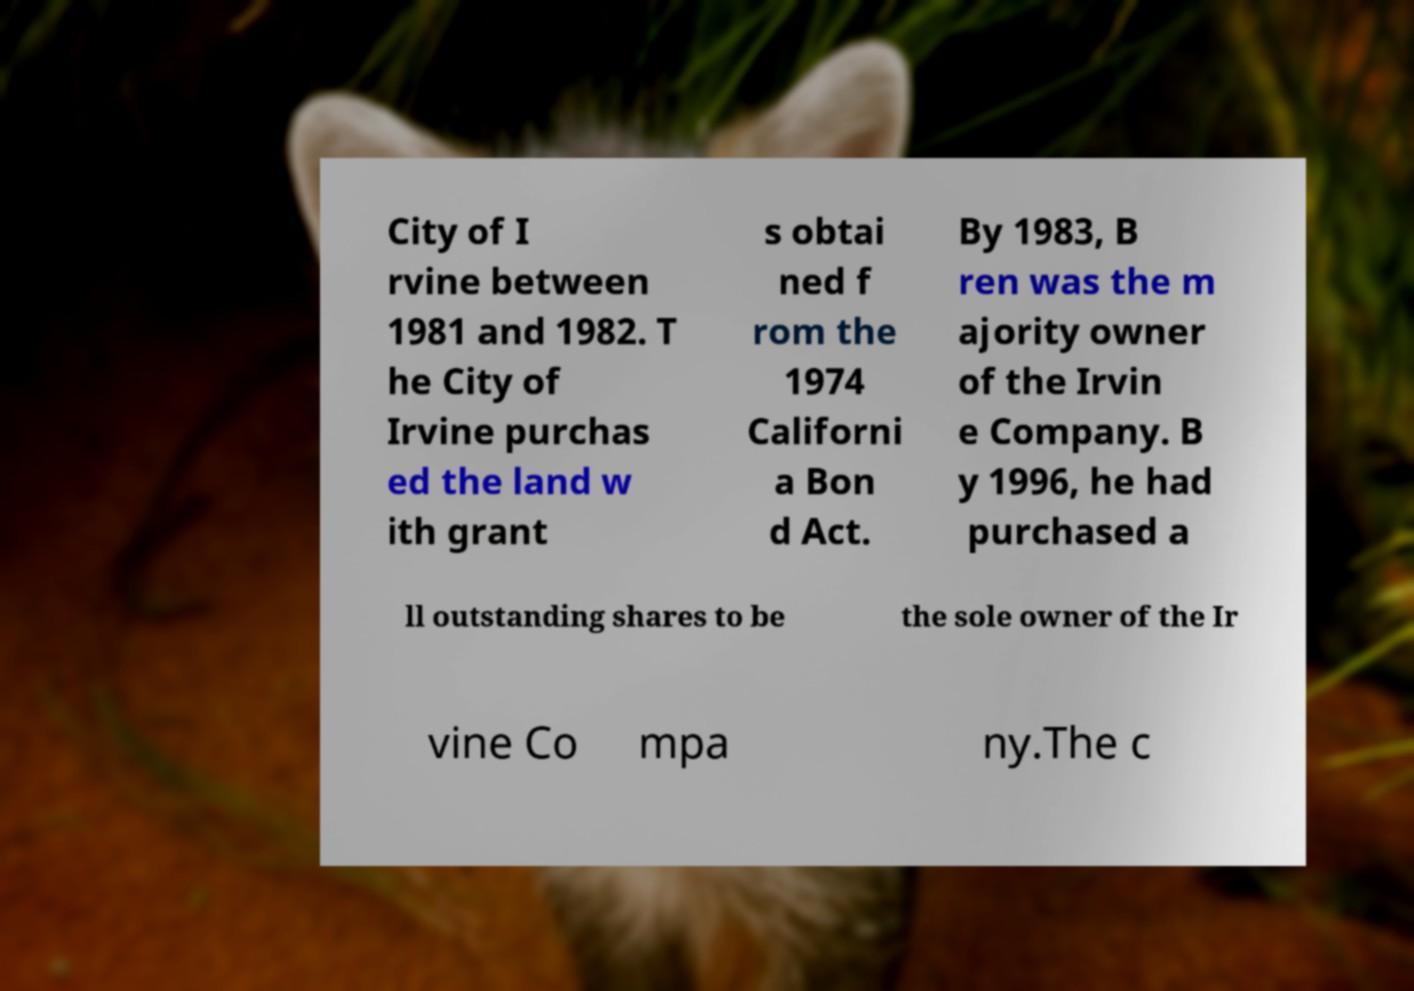For documentation purposes, I need the text within this image transcribed. Could you provide that? City of I rvine between 1981 and 1982. T he City of Irvine purchas ed the land w ith grant s obtai ned f rom the 1974 Californi a Bon d Act. By 1983, B ren was the m ajority owner of the Irvin e Company. B y 1996, he had purchased a ll outstanding shares to be the sole owner of the Ir vine Co mpa ny.The c 